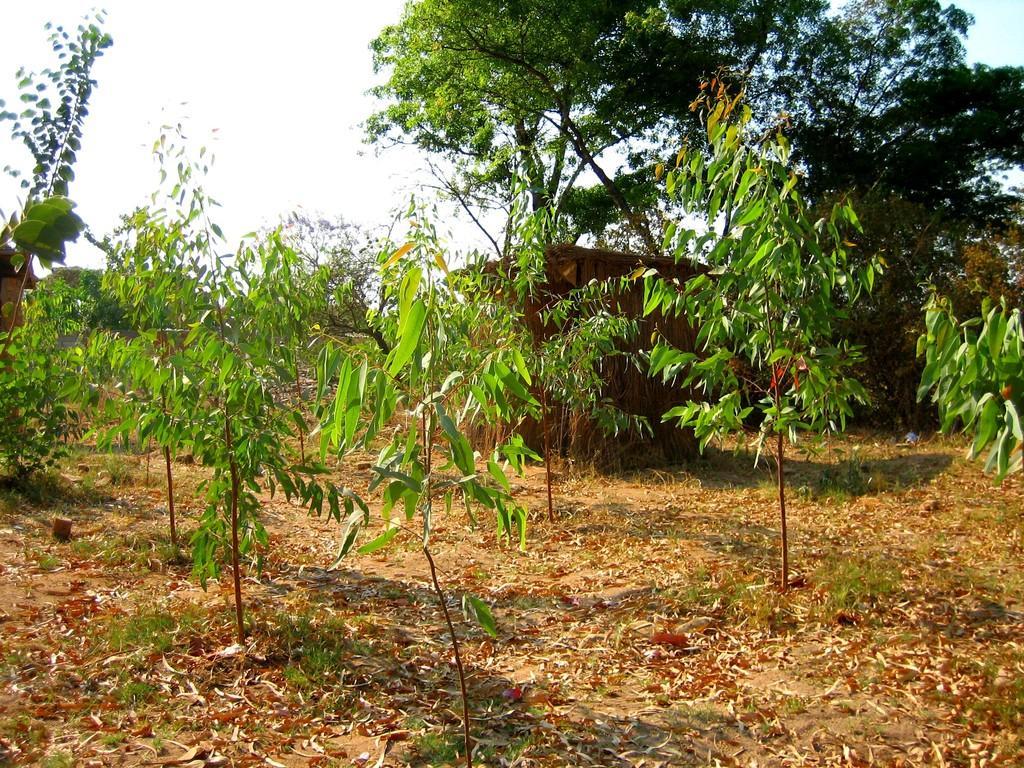Can you describe this image briefly? In this image we can see trees and plants. In the middle of the image one hut is there and on land dry leaves are present. 